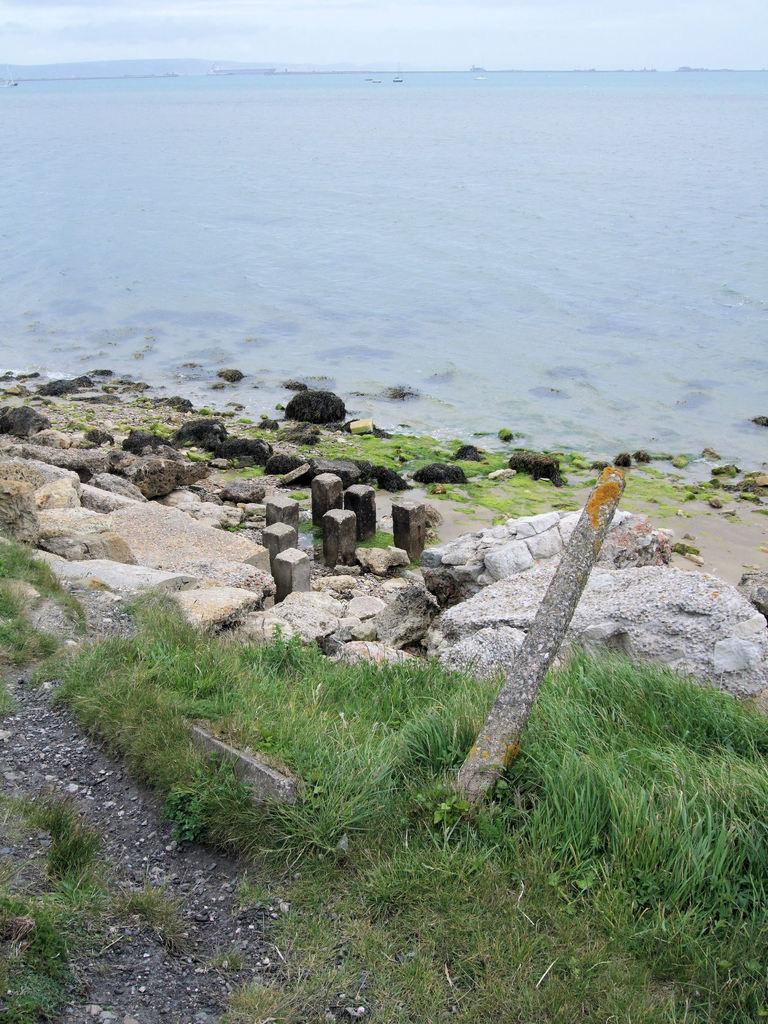Could you give a brief overview of what you see in this image? In this image few rocks are on the land having some grass. There are few boats sailing on water. Left top there is a hill. Top of the image there is sky. 